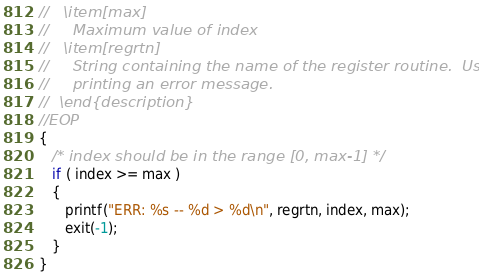Convert code to text. <code><loc_0><loc_0><loc_500><loc_500><_C_>//   \item[max]
//     Maximum value of index
//   \item[regrtn]
//     String containing the name of the register routine.  Used for
//     printing an error message.
//  \end{description}
//EOP
{
   /* index should be in the range [0, max-1] */
   if ( index >= max )
   {
      printf("ERR: %s -- %d > %d\n", regrtn, index, max);
      exit(-1);
   }
}
</code> 